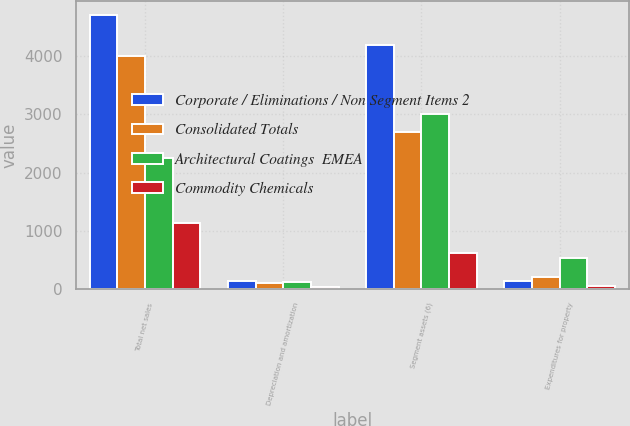Convert chart. <chart><loc_0><loc_0><loc_500><loc_500><stacked_bar_chart><ecel><fcel>Total net sales<fcel>Depreciation and amortization<fcel>Segment assets (6)<fcel>Expenditures for property<nl><fcel>Corporate / Eliminations / Non Segment Items 2<fcel>4716<fcel>133<fcel>4190<fcel>139<nl><fcel>Consolidated Totals<fcel>3999<fcel>109<fcel>2699<fcel>198<nl><fcel>Architectural Coatings  EMEA<fcel>2249<fcel>121<fcel>3003<fcel>525<nl><fcel>Commodity Chemicals<fcel>1138<fcel>36<fcel>615<fcel>49<nl></chart> 